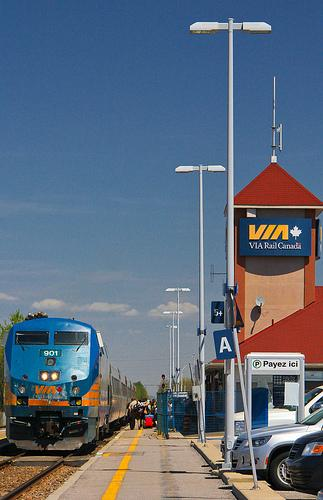Describe the lighting elements present in the scene. There are three tall street lamp poles, two illuminated headlights on the front of the train, and red signal lights near the train track. Provide a description of the primary mode of transportation in the image. A blue-orange-silver passenger train with the white number 901 written on it is stationed on metal train tracks. Describe any signs or banners present in the image. There are signs that say "VIA Rail Canada," "Payez," "ICI," and "VIA" in yellow letters, as well as a sign with a letter 'A' and another with the number five and a plus sign. Give a brief summary of the vehicles present in the image. There is a very front part of a black vehicle and a silver car parked next to it near the train track. Detail any borders or barriers seen within the image. There is a blue metal fence close to the train track and a yellow line painted on a platform. List the objects seen in the sky portion of the image. The sky has a section of blue sky and a few white clouds in it. List down any tech-related objects or features present in the image. There is a wall-mounted satellite dish and a silver phone booth in the image. Describe the people in the image and their activity. Several people are standing together near the train, and a dark-skinned policeman stands by as well. Mention any luggage or personal items in the image. There is a red roller suitcase and a red suit case visible in the scene. Mention any unique features or landmarks that are visible in the image. There is a blue sign with the letter 'A' on it, a sign displaying "VIA Rail Canada" in large orange letters and a silver phone booth that says "PAEZ." 